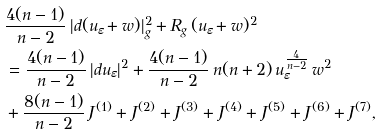Convert formula to latex. <formula><loc_0><loc_0><loc_500><loc_500>& \frac { 4 ( n - 1 ) } { n - 2 } \, | d ( u _ { \varepsilon } + w ) | _ { g } ^ { 2 } + R _ { g } \, ( u _ { \varepsilon } + w ) ^ { 2 } \\ & = \frac { 4 ( n - 1 ) } { n - 2 } \, | d u _ { \varepsilon } | ^ { 2 } + \frac { 4 ( n - 1 ) } { n - 2 } \, n ( n + 2 ) \, u _ { \varepsilon } ^ { \frac { 4 } { n - 2 } } \, w ^ { 2 } \\ & + \frac { 8 ( n - 1 ) } { n - 2 } \, J ^ { ( 1 ) } + J ^ { ( 2 ) } + J ^ { ( 3 ) } + J ^ { ( 4 ) } + J ^ { ( 5 ) } + J ^ { ( 6 ) } + J ^ { ( 7 ) } ,</formula> 